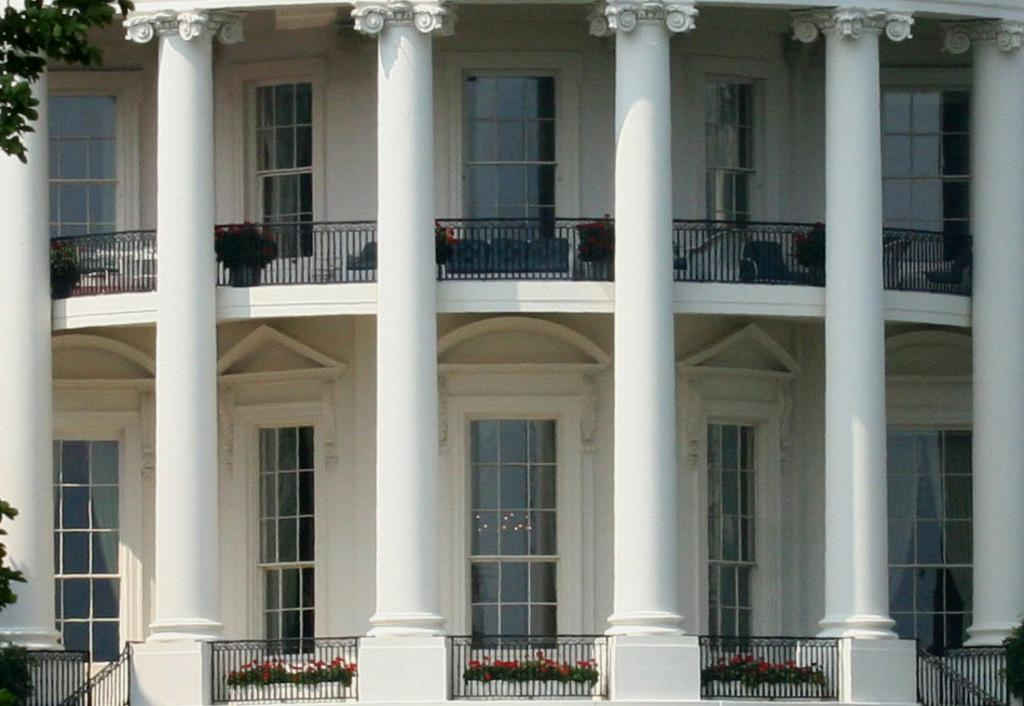What type of structure is present in the image? There is a building in the image. What other objects can be seen in the image? There are plants in pots and tree branches with leaves visible in the image. What is the reason for the protest happening in front of the building in the image? There is no protest happening in front of the building in the image. 